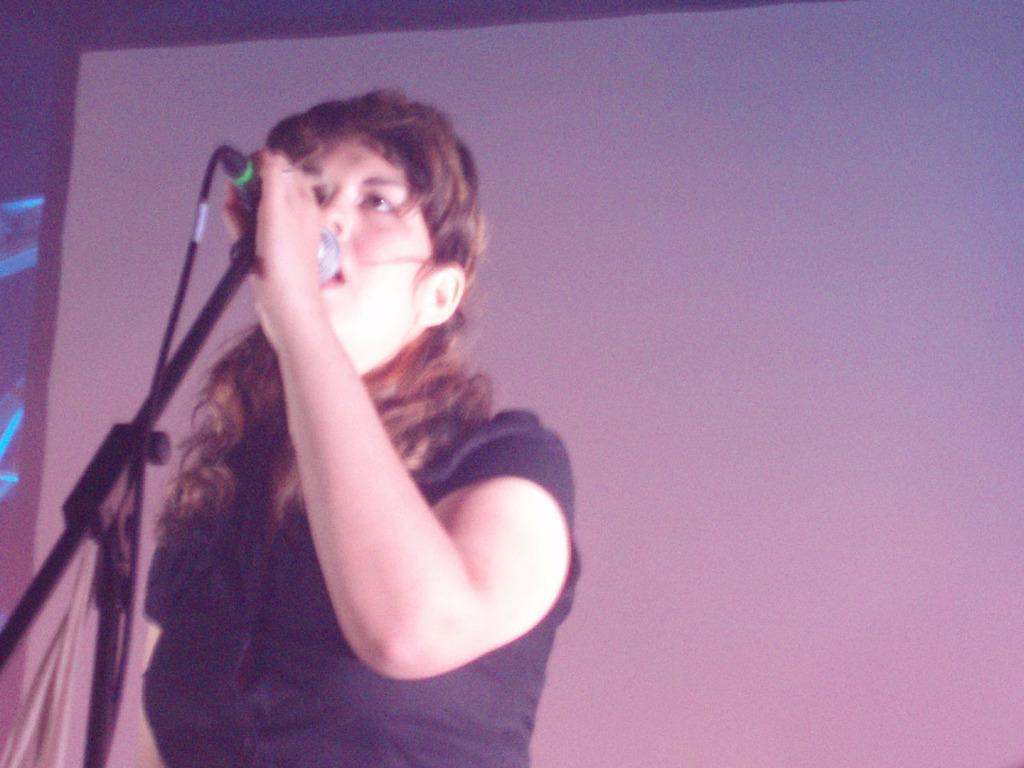Who is the main subject in the image? There is a woman in the image. What is the woman doing in the image? The woman is standing and holding a microphone. What can be seen in the background of the image? There is a screen in the background of the image. Is there any smoke visible in the image? No, there is no smoke present in the image. What type of test is the woman conducting in the image? There is no test being conducted in the image; the woman is holding a microphone. 